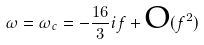Convert formula to latex. <formula><loc_0><loc_0><loc_500><loc_500>\omega = \omega _ { c } = - \frac { 1 6 } { 3 } i f + \text {O} ( f ^ { 2 } )</formula> 